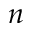Convert formula to latex. <formula><loc_0><loc_0><loc_500><loc_500>n</formula> 